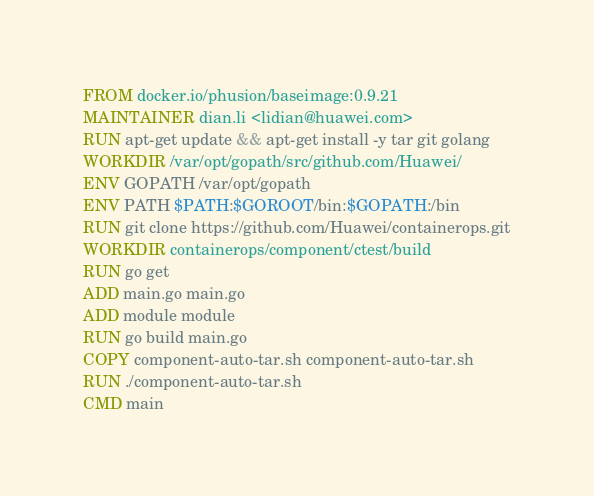<code> <loc_0><loc_0><loc_500><loc_500><_Dockerfile_>FROM docker.io/phusion/baseimage:0.9.21
MAINTAINER dian.li <lidian@huawei.com>
RUN apt-get update && apt-get install -y tar git golang
WORKDIR /var/opt/gopath/src/github.com/Huawei/
ENV GOPATH /var/opt/gopath
ENV PATH $PATH:$GOROOT/bin:$GOPATH:/bin
RUN git clone https://github.com/Huawei/containerops.git
WORKDIR containerops/component/ctest/build
RUN go get
ADD main.go main.go
ADD module module
RUN go build main.go
COPY component-auto-tar.sh component-auto-tar.sh
RUN ./component-auto-tar.sh
CMD main


</code> 